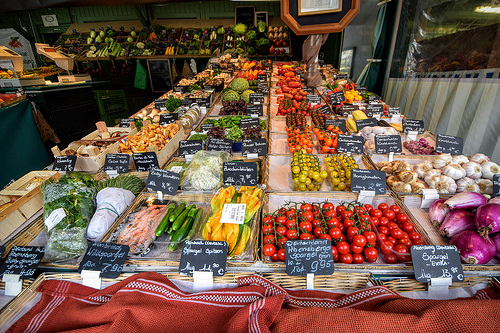<image>
Is there a tomato to the right of the brinjal? No. The tomato is not to the right of the brinjal. The horizontal positioning shows a different relationship. 